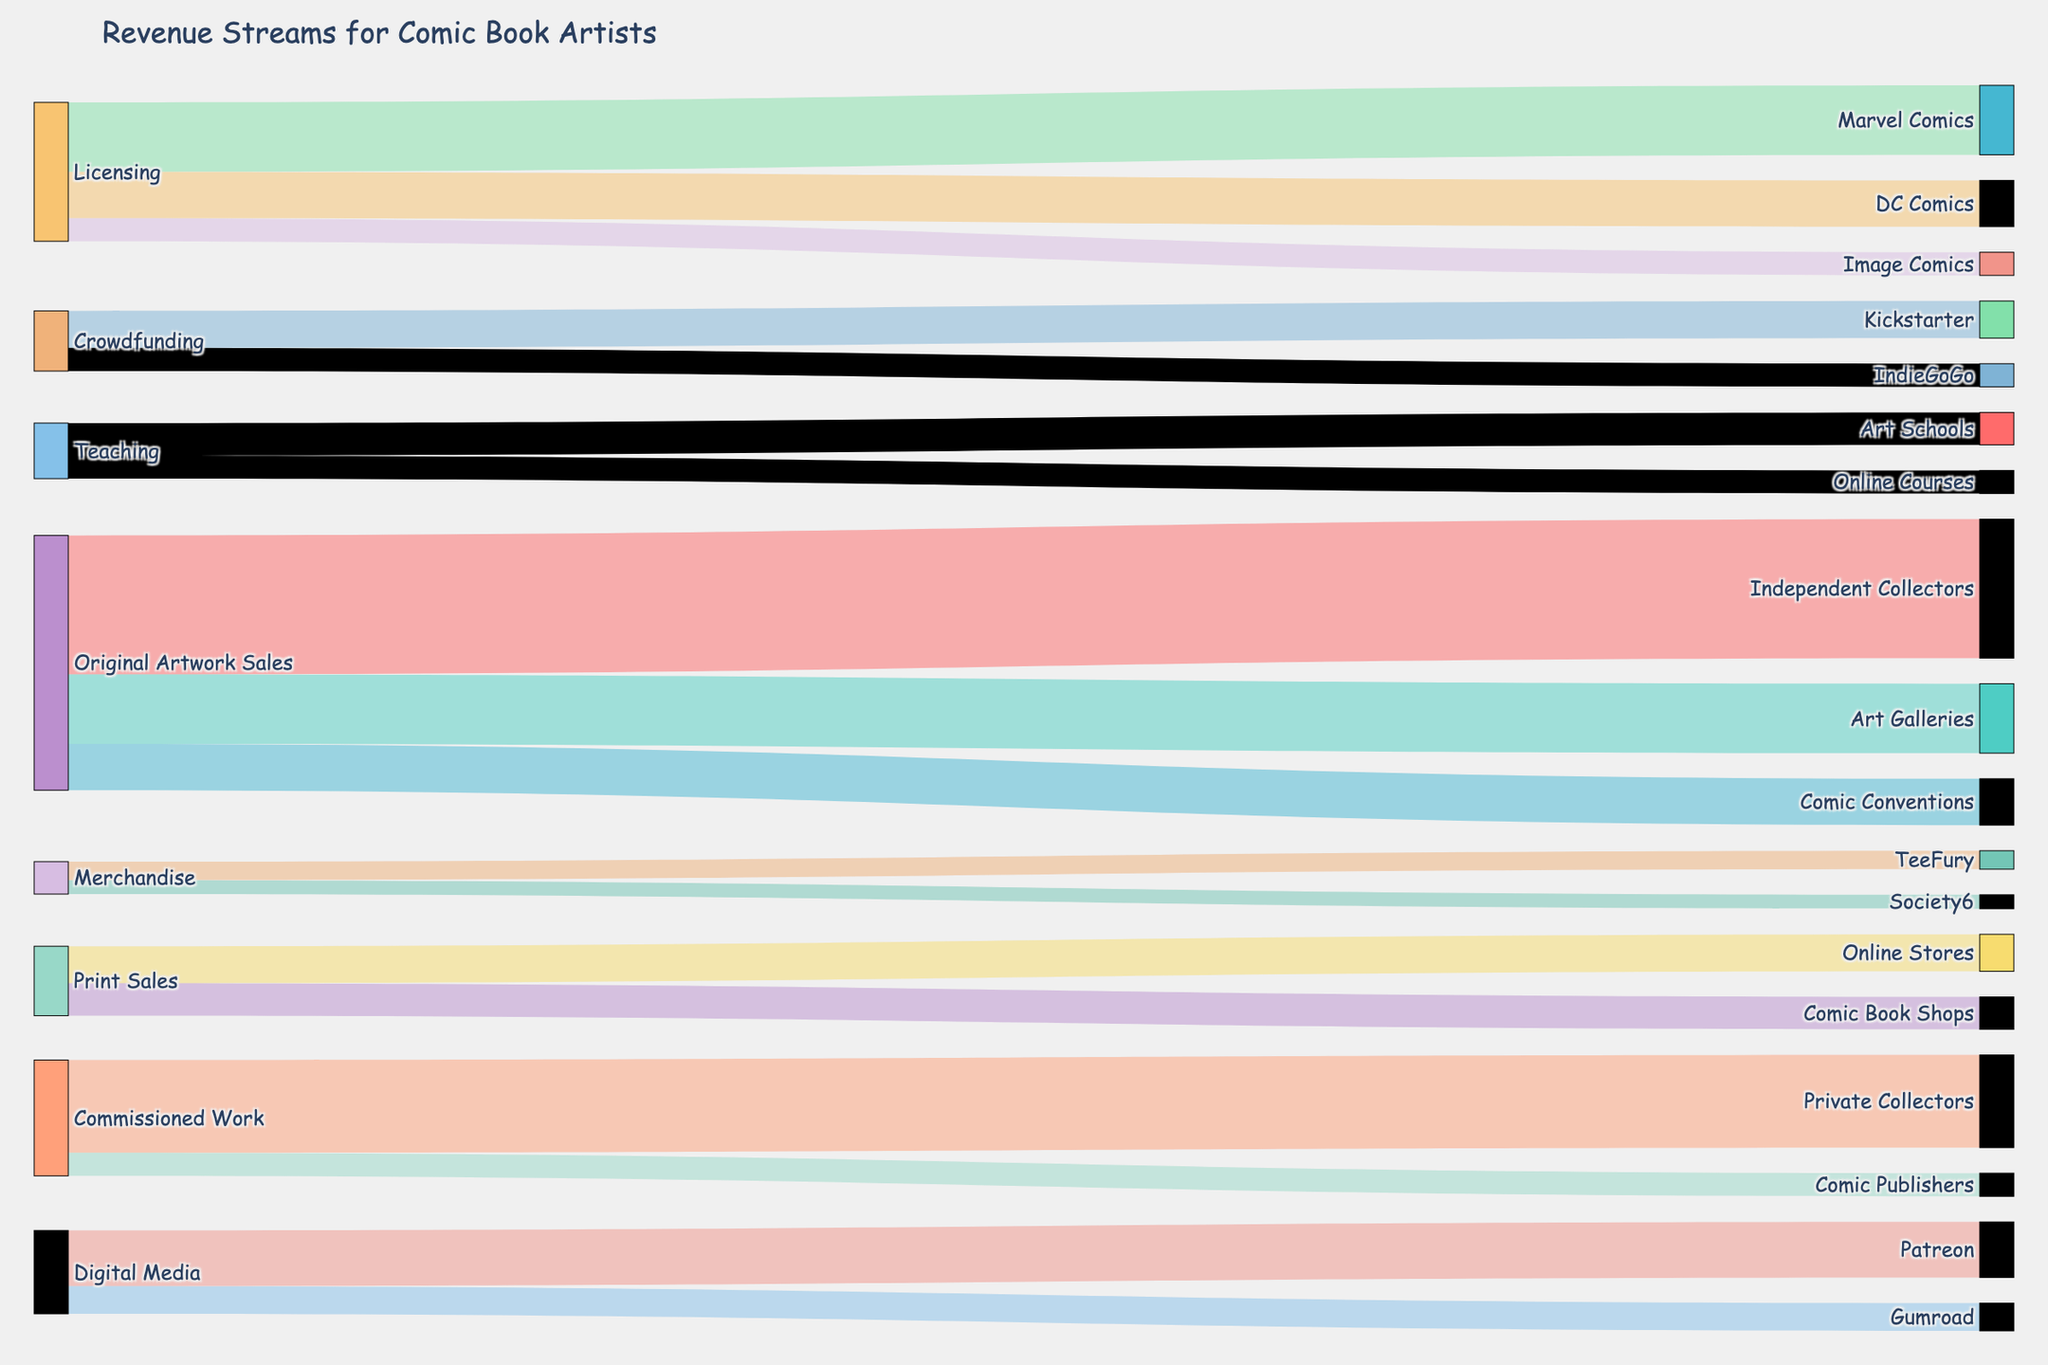What is the largest single revenue stream for comic book artists? Look at the widths of the streams arising from each revenue source. The widest stream correlates to the highest value. "Original Artwork Sales to Independent Collectors" is the largest with a width representing a value of 30.
Answer: Original Artwork Sales to Independent Collectors Which revenue stream involves both Marvel Comics and DC Comics? Examine the target nodes and find which source nodes lead to both Marvel Comics and DC Comics. "Licensing" is connected to both Marvel Comics and DC Comics.
Answer: Licensing How much revenue comes from digital media sources? Identify all the connections originating from "Digital Media" and sum their values. There are two connections: Patreon (12) and Gumroad (6), so 12 + 6 gives us the total revenue from digital media.
Answer: 18 What is the total revenue from crowdfunding sources? Locate the "Crowdfunding" node and sum the values of all outgoing streams. Kickstarter (8) and IndieGoGo (5), summing to 13.
Answer: 13 Compared to online stores, how much do comic book shops contribute to print sales? Identify the values for "Print Sales to Online Stores" and "Print Sales to Comic Book Shops". Compare 8 (Online Stores) to 7 (Comic Book Shops). Online stores have a value of 1 more than comic book shops.
Answer: 1 more to Online Stores Which platforms are used for teaching? Look at the node labels and locate all connections originating from the "Teaching" node. The teaching node has streams to both "Art Schools" and "Online Courses".
Answer: Art Schools and Online Courses What proportion of the revenue from licensing comes from Marvel Comics? Quantify the revenue from "Licensing" and determine what fraction comes from Marvel Comics. Licensing totals are from Marvel Comics (15), DC Comics (10), and Image Comics (5), summing to 30. The proportion for Marvel Comics is 15/30 or 1/2.
Answer: 1/2 How does the revenue from commissioned work compare between private collectors and comic publishers? Find and compare the values for "Commissioned Work to Private Collectors" and "Commissioned Work to Comic Publishers". The values are 20 for Private Collectors and 5 for Comic Publishers, showing Private Collectors bring in 15 more.
Answer: 15 more for Private Collectors Which channels contribute to the sale of original artwork? Identify the connections originating from "Original Artwork Sales". The paths lead to Independent Collectors (30), Art Galleries (15), and Comic Conventions (10).
Answer: Independent Collectors, Art Galleries, Comic Conventions 